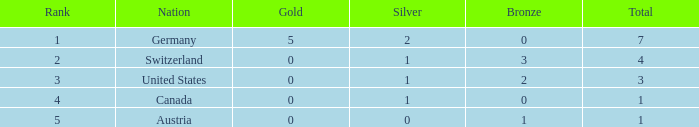How many bronze items are present when the total is less than 1? None. 